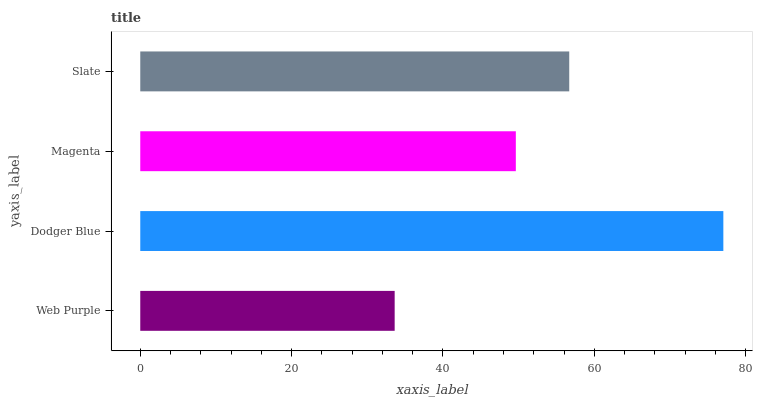Is Web Purple the minimum?
Answer yes or no. Yes. Is Dodger Blue the maximum?
Answer yes or no. Yes. Is Magenta the minimum?
Answer yes or no. No. Is Magenta the maximum?
Answer yes or no. No. Is Dodger Blue greater than Magenta?
Answer yes or no. Yes. Is Magenta less than Dodger Blue?
Answer yes or no. Yes. Is Magenta greater than Dodger Blue?
Answer yes or no. No. Is Dodger Blue less than Magenta?
Answer yes or no. No. Is Slate the high median?
Answer yes or no. Yes. Is Magenta the low median?
Answer yes or no. Yes. Is Dodger Blue the high median?
Answer yes or no. No. Is Dodger Blue the low median?
Answer yes or no. No. 